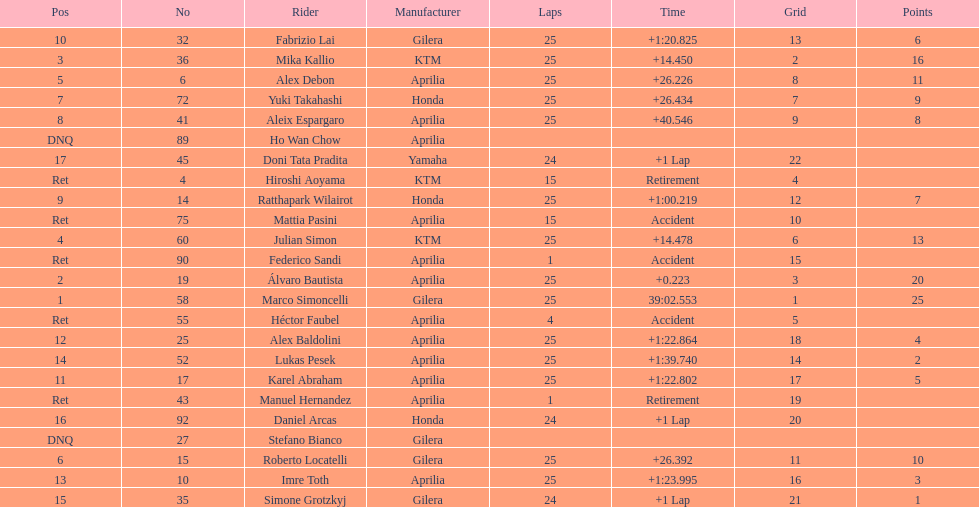The total amount of riders who did not qualify 2. 